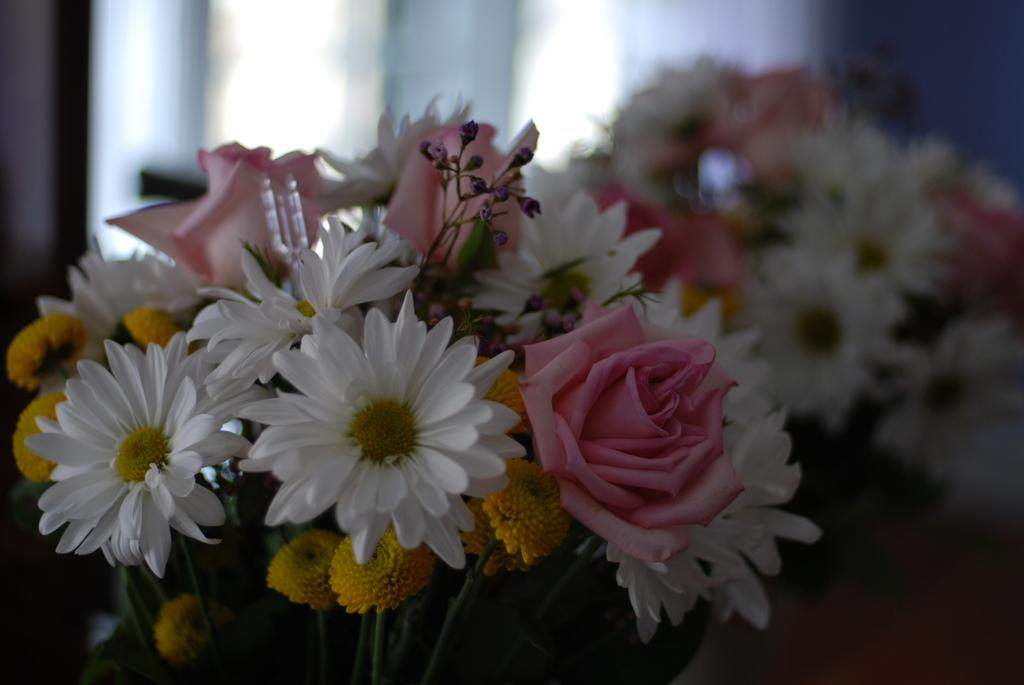What type of plants can be seen in the image? There are flowers in the image. What part of the flowers is visible in the image? There are stems in the image. Can you describe the background of the image? The background of the image is blurred. What time of day is depicted in the image? The image does not depict a specific time of day, so it cannot be determined if it is the afternoon or any other time. 